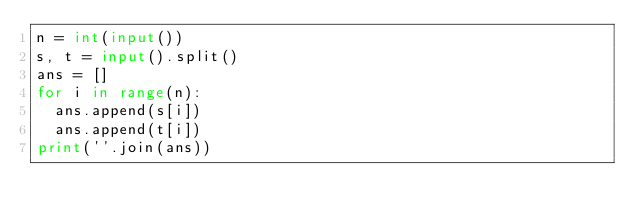Convert code to text. <code><loc_0><loc_0><loc_500><loc_500><_Python_>n = int(input())
s, t = input().split()
ans = []
for i in range(n):
  ans.append(s[i])
  ans.append(t[i])
print(''.join(ans))</code> 